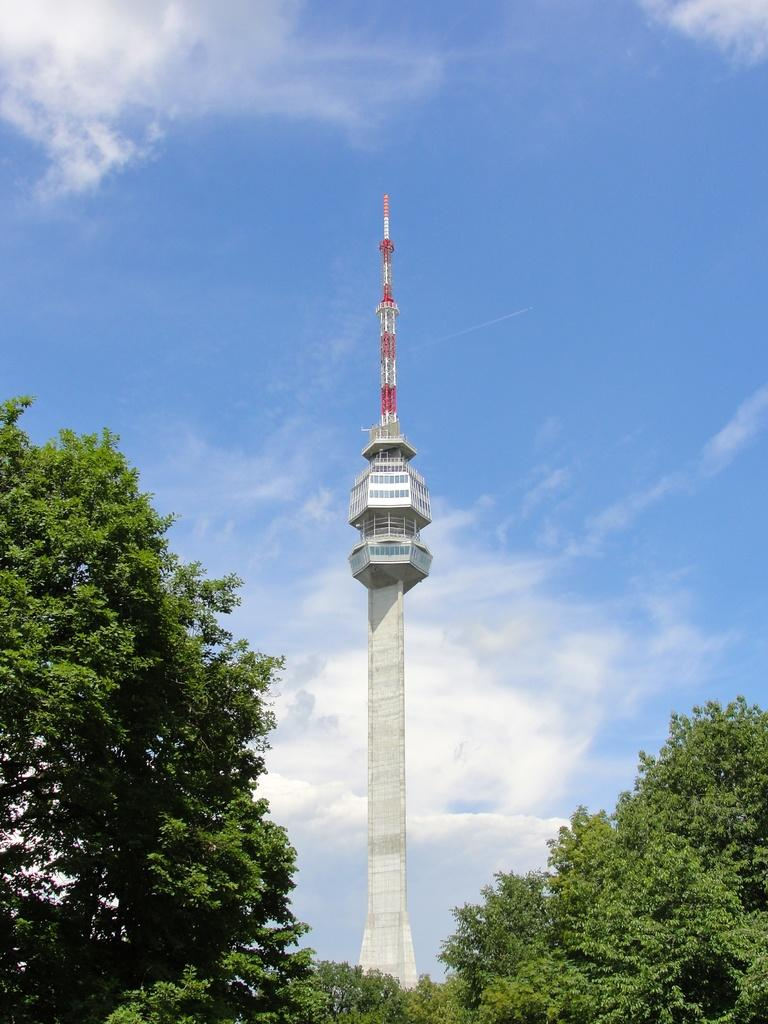What is the main structure in the image? There is a tower in the image. What type of vegetation can be seen in the image? There are trees in the image. What is visible in the sky in the image? There are clouds visible in the image. What time of day is it in the image, considering the presence of love? The presence of love is not mentioned in the image, and therefore it cannot be used to determine the time of day. 